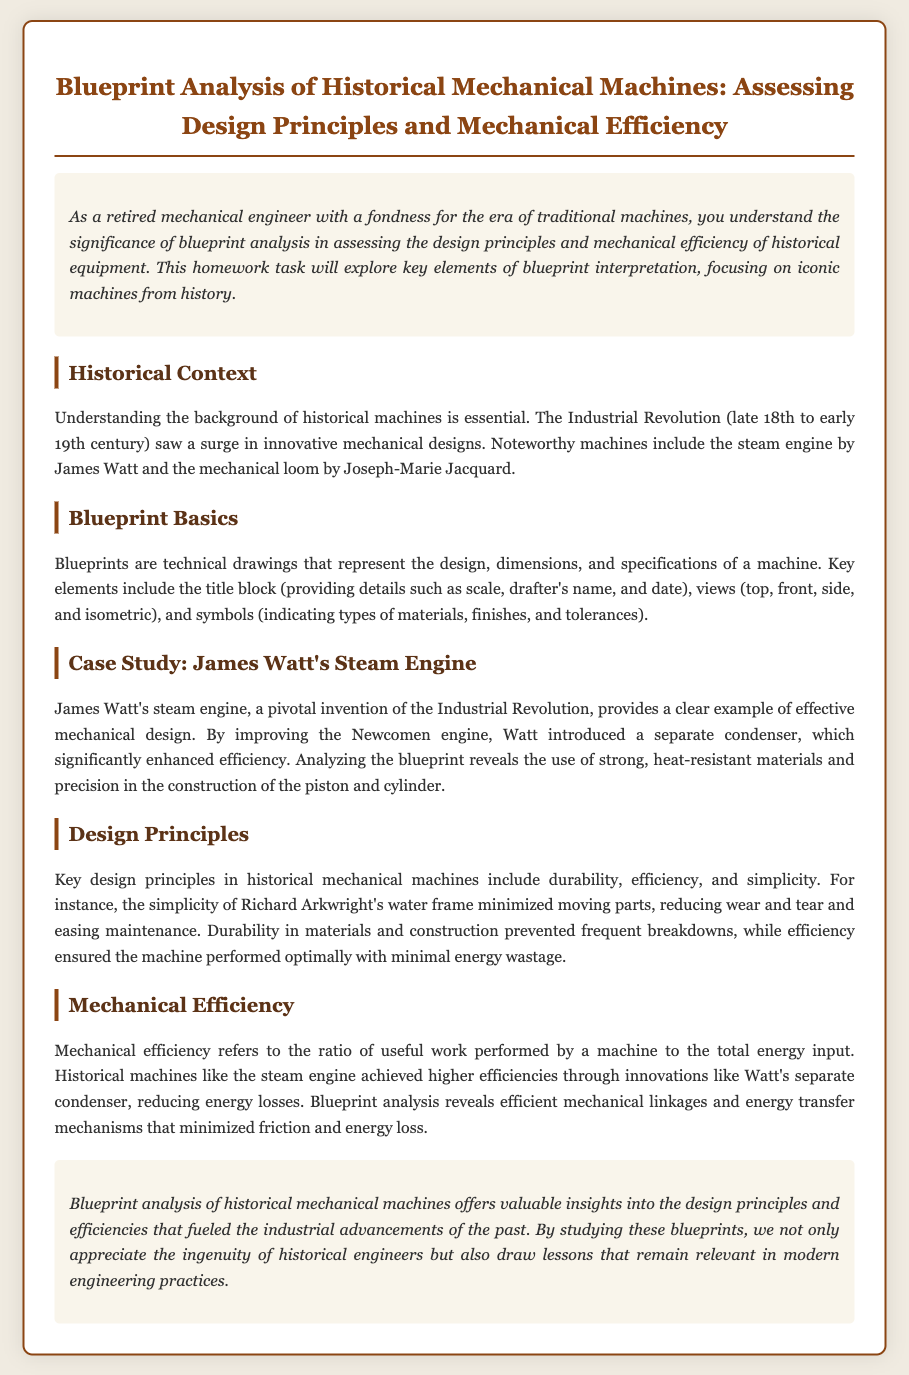What is the title of the document? The title of the document is found in the heading section, introducing the main topic of the homework.
Answer: Blueprint Analysis of Historical Mechanical Machines: Assessing Design Principles and Mechanical Efficiency Who improved the Newcomen engine? The document provides specific information about the individual who made significant improvements to the Newcomen engine in the case study section.
Answer: James Watt What key design principle minimizes moving parts? This question pertains to identifying a specific design principle discussed in the design principles section of the document.
Answer: Simplicity What is the main focus of the homework task? The main focus of the homework is described in the introductory paragraph, outlining the purpose of the analysis.
Answer: Blueprint analysis What did Watt introduce to enhance efficiency? This information is specified in the case study section regarding innovations by Watt that improved efficiency in the steam engine.
Answer: Separate condenser What era did the Industrial Revolution occur in? The document indicates the timeframe of the Industrial Revolution in the historical context section.
Answer: Late 18th to early 19th century What type of drawings represent the design of a machine? The document specifies the type of technical drawings discussed in the blueprint basics section.
Answer: Blueprints What ratio does mechanical efficiency refer to? This aspect is defined in the section discussing mechanical efficiency, explaining its significance.
Answer: Useful work performed to total energy input 